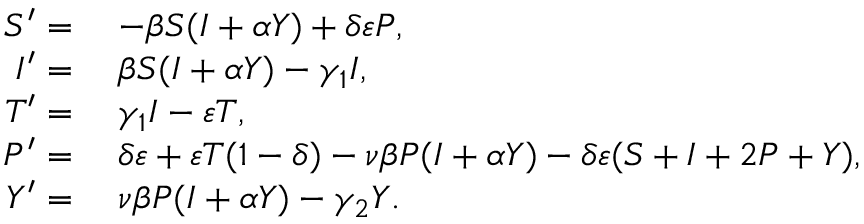<formula> <loc_0><loc_0><loc_500><loc_500>\begin{array} { r l } { S ^ { \prime } = } & { \, - \beta S ( I + \alpha Y ) + \delta \varepsilon P , } \\ { I ^ { \prime } = } & { \, \beta S ( I + \alpha Y ) - \gamma _ { 1 } I , } \\ { T ^ { \prime } = } & { \, \gamma _ { 1 } I - \varepsilon T , } \\ { P ^ { \prime } = } & { \, \delta \varepsilon + \varepsilon T ( 1 - \delta ) - \nu \beta P ( I + \alpha Y ) - \delta \varepsilon ( S + I + 2 P + Y ) , } \\ { Y ^ { \prime } = } & { \, \nu \beta P ( I + \alpha Y ) - \gamma _ { 2 } Y . } \end{array}</formula> 